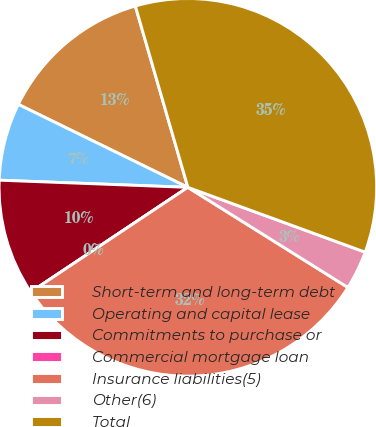<chart> <loc_0><loc_0><loc_500><loc_500><pie_chart><fcel>Short-term and long-term debt<fcel>Operating and capital lease<fcel>Commitments to purchase or<fcel>Commercial mortgage loan<fcel>Insurance liabilities(5)<fcel>Other(6)<fcel>Total<nl><fcel>13.27%<fcel>6.64%<fcel>9.96%<fcel>0.0%<fcel>31.75%<fcel>3.32%<fcel>35.07%<nl></chart> 